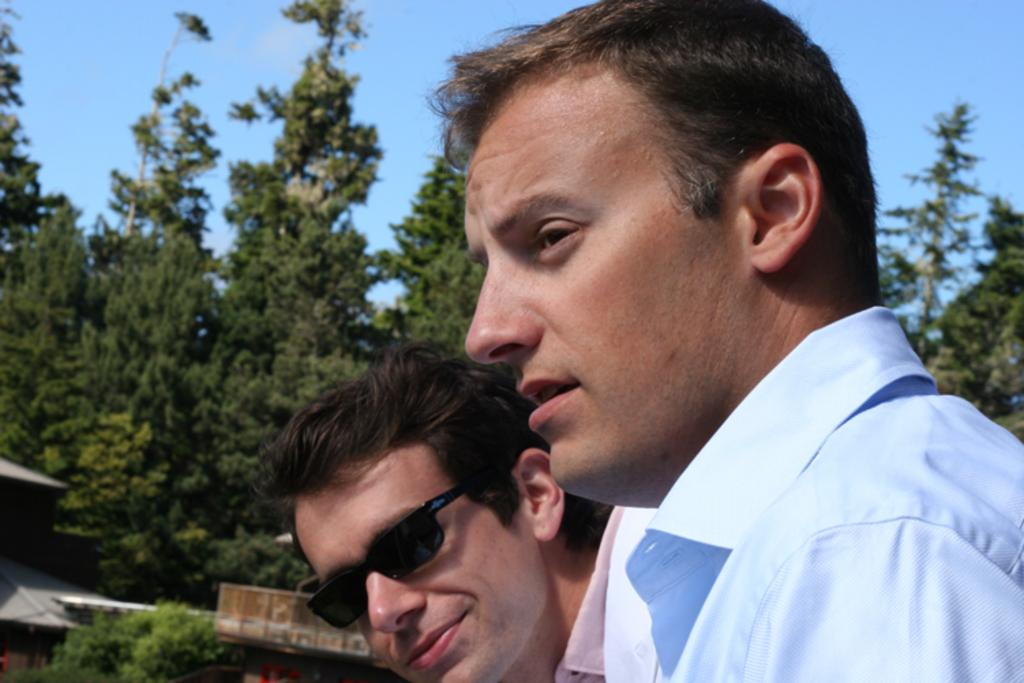How many people are in the foreground of the image? There are two people in the foreground of the image. What is one person wearing in the image? One person is wearing goggles. What can be seen in the background of the image? There are trees and houses in the background of the image. What is visible at the top of the image? The sky is visible at the top of the image. What type of stove can be seen in the image? There is no stove present in the image. How many balloons are being held by the person wearing goggles? There are no balloons visible in the image. 